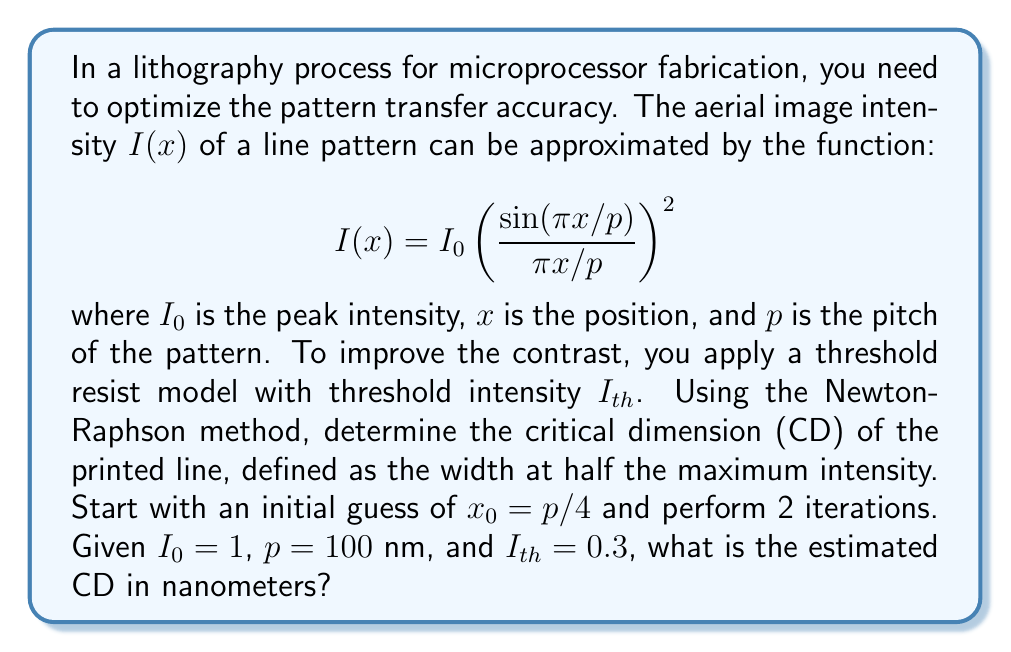Provide a solution to this math problem. To solve this problem, we'll follow these steps:

1) First, we need to find the equation for the half-maximum intensity:

   $$I(x) = \frac{I_0}{2} = 0.5$$

2) Substituting the given function:

   $$0.5 = \left(\frac{\sin(\pi x/p)}{\pi x/p}\right)^2$$

3) Let's define a function $f(x)$ that we want to find the root of:

   $$f(x) = \left(\frac{\sin(\pi x/p)}{\pi x/p}\right)^2 - 0.5$$

4) The Newton-Raphson method is given by:

   $$x_{n+1} = x_n - \frac{f(x_n)}{f'(x_n)}$$

5) We need to find $f'(x)$:

   $$f'(x) = 2\left(\frac{\sin(\pi x/p)}{\pi x/p}\right) \cdot \frac{d}{dx}\left(\frac{\sin(\pi x/p)}{\pi x/p}\right)$$

   $$= 2\left(\frac{\sin(\pi x/p)}{\pi x/p}\right) \cdot \left(\frac{\pi}{p}\cos(\pi x/p) \cdot \frac{\pi x/p} - \sin(\pi x/p) \cdot \pi/p}{(\pi x/p)^2}\right)$$

   $$= \frac{2\pi}{p}\left(\frac{\sin(\pi x/p)}{\pi x/p}\right) \cdot \left(\frac{\cos(\pi x/p)}{x} - \frac{\sin(\pi x/p)}{(\pi x^2/p)}\right)$$

6) Now, let's perform 2 iterations:

   Iteration 1:
   $x_0 = p/4 = 25$ nm
   
   $$f(25) = \left(\frac{\sin(\pi \cdot 25/100)}{\pi \cdot 25/100}\right)^2 - 0.5 = 0.2026$$
   
   $$f'(25) = \frac{2\pi}{100}\left(\frac{\sin(\pi \cdot 25/100)}{\pi \cdot 25/100}\right) \cdot \left(\frac{\cos(\pi \cdot 25/100)}{25} - \frac{\sin(\pi \cdot 25/100)}{(\pi \cdot 25^2/100)}\right) = -0.0338$$
   
   $$x_1 = 25 - \frac{0.2026}{-0.0338} = 31.0012\text{ nm}$$

   Iteration 2:
   
   $$f(31.0012) = \left(\frac{\sin(\pi \cdot 31.0012/100)}{\pi \cdot 31.0012/100}\right)^2 - 0.5 = -0.0004$$
   
   $$f'(31.0012) = \frac{2\pi}{100}\left(\frac{\sin(\pi \cdot 31.0012/100)}{\pi \cdot 31.0012/100}\right) \cdot \left(\frac{\cos(\pi \cdot 31.0012/100)}{31.0012} - \frac{\sin(\pi \cdot 31.0012/100)}{(\pi \cdot 31.0012^2/100)}\right) = -0.0275$$
   
   $$x_2 = 31.0012 - \frac{-0.0004}{-0.0275} = 30.9867\text{ nm}$$

7) The CD is twice this value, as it represents the full width of the line:

   CD = $2 \cdot 30.9867 = 61.9734$ nm

Therefore, the estimated CD after 2 iterations is approximately 61.97 nm.
Answer: 61.97 nm 